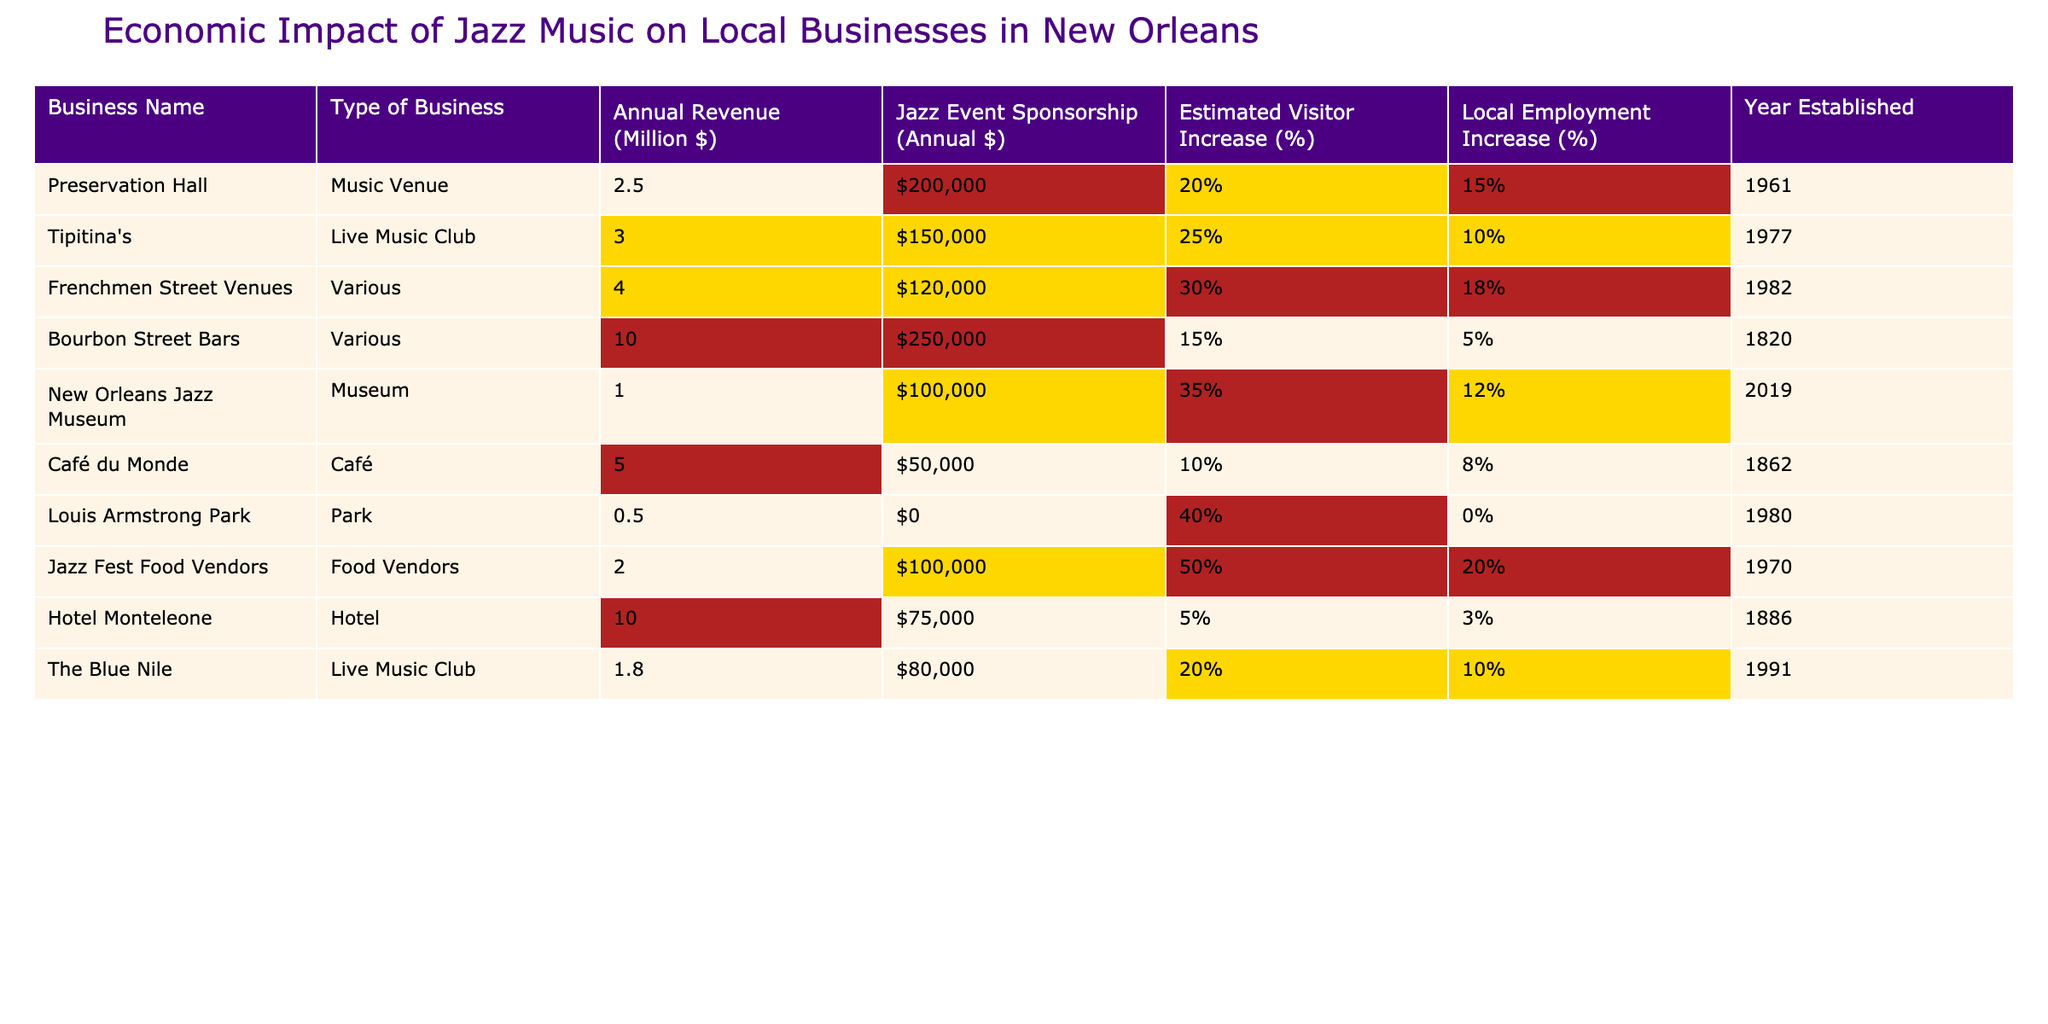What is the annual revenue of Preservation Hall? The table lists Preservation Hall under the "Annual Revenue (Million $)" column, which shows a value of 2.5 million dollars.
Answer: 2.5 million dollars Which business has the highest annual revenue? By comparing the values in the "Annual Revenue (Million $)" column, Bourbon Street Bars has the highest revenue at 10 million dollars.
Answer: Bourbon Street Bars What percentage of estimated visitor increase is associated with Jazz Fest Food Vendors? The table indicates that Jazz Fest Food Vendors have an estimated visitor increase of 50%, which is stated in the "Estimated Visitor Increase (%)" column.
Answer: 50% Which business has the longest history based on the year established? The year established for each business is provided in the last column. Bourbon Street Bars was established in 1820, making it the oldest business on the list.
Answer: Bourbon Street Bars How much jazz event sponsorship does Tipitina's receive annually? Looking at the "Jazz Event Sponsorship (Annual $)" column, Tipitina's sponsorship is listed as 150,000 dollars.
Answer: 150,000 dollars Is the local employment increase at the New Orleans Jazz Museum higher than at Café du Monde? For local employment increase, New Orleans Jazz Museum shows 12%, while Café du Monde shows 8%. Since 12% is greater than 8%, the statement is true.
Answer: Yes Calculate the total annual revenue of all businesses listed. The total annual revenue can be calculated by summing the annual revenues: 2.5 + 3.0 + 4.0 + 10.0 + 1.0 + 5.0 + 0.5 + 2.0 + 10.0 + 1.8 = 40.8 million dollars.
Answer: 40.8 million dollars Which type of business has the highest local employment increase percentage? Comparing the "Local Employment Increase (%)" values, Jazz Fest Food Vendors have the highest local employment increase at 20%.
Answer: Jazz Fest Food Vendors Are there any businesses with zero annual jazz event sponsorship? Louis Armstrong Park shows an annual jazz event sponsorship of 0 dollars, meaning it does not contribute any sponsorship funds.
Answer: Yes What is the average estimated visitor increase percentage among the listed businesses? To find the average, sum the percentages: (20 + 25 + 30 + 15 + 35 + 10 + 40 + 50 + 5 + 20) = 250, then divide by 10 (the number of businesses), resulting in an average of 25%.
Answer: 25% 